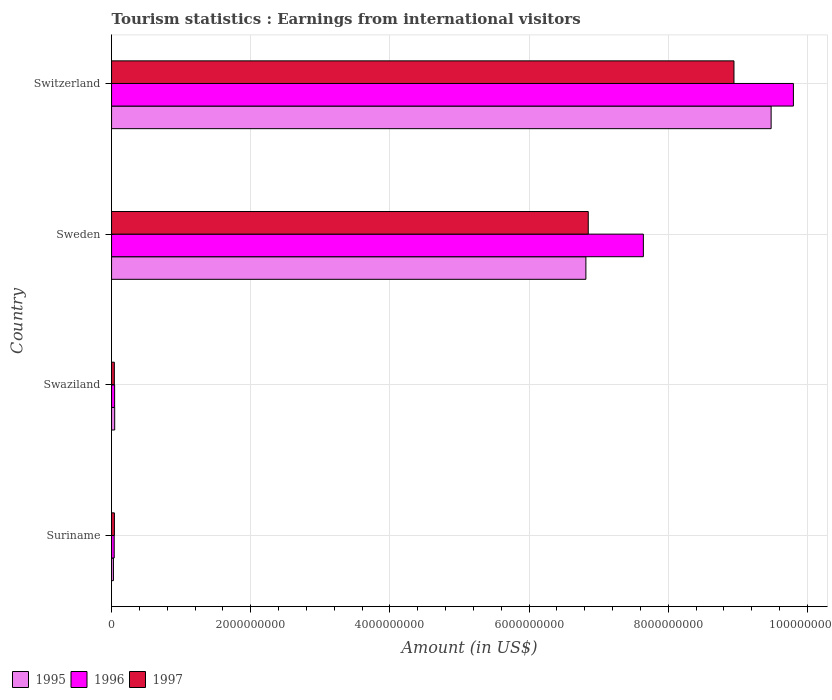How many bars are there on the 4th tick from the top?
Offer a terse response. 3. How many bars are there on the 3rd tick from the bottom?
Ensure brevity in your answer.  3. What is the label of the 2nd group of bars from the top?
Keep it short and to the point. Sweden. What is the earnings from international visitors in 1996 in Swaziland?
Your answer should be compact. 4.40e+07. Across all countries, what is the maximum earnings from international visitors in 1995?
Your answer should be very brief. 9.48e+09. Across all countries, what is the minimum earnings from international visitors in 1996?
Your answer should be compact. 3.80e+07. In which country was the earnings from international visitors in 1996 maximum?
Your answer should be very brief. Switzerland. In which country was the earnings from international visitors in 1996 minimum?
Your answer should be compact. Suriname. What is the total earnings from international visitors in 1996 in the graph?
Provide a short and direct response. 1.75e+1. What is the difference between the earnings from international visitors in 1996 in Swaziland and that in Sweden?
Provide a short and direct response. -7.60e+09. What is the difference between the earnings from international visitors in 1997 in Suriname and the earnings from international visitors in 1996 in Swaziland?
Keep it short and to the point. -3.00e+06. What is the average earnings from international visitors in 1997 per country?
Provide a succinct answer. 3.97e+09. What is the difference between the earnings from international visitors in 1996 and earnings from international visitors in 1995 in Sweden?
Offer a terse response. 8.26e+08. What is the ratio of the earnings from international visitors in 1995 in Suriname to that in Switzerland?
Ensure brevity in your answer.  0. Is the earnings from international visitors in 1996 in Sweden less than that in Switzerland?
Your response must be concise. Yes. Is the difference between the earnings from international visitors in 1996 in Swaziland and Sweden greater than the difference between the earnings from international visitors in 1995 in Swaziland and Sweden?
Keep it short and to the point. No. What is the difference between the highest and the second highest earnings from international visitors in 1997?
Give a very brief answer. 2.09e+09. What is the difference between the highest and the lowest earnings from international visitors in 1996?
Make the answer very short. 9.76e+09. What does the 2nd bar from the top in Swaziland represents?
Offer a very short reply. 1996. Are all the bars in the graph horizontal?
Your answer should be very brief. Yes. What is the difference between two consecutive major ticks on the X-axis?
Provide a short and direct response. 2.00e+09. Are the values on the major ticks of X-axis written in scientific E-notation?
Ensure brevity in your answer.  No. What is the title of the graph?
Give a very brief answer. Tourism statistics : Earnings from international visitors. What is the label or title of the X-axis?
Provide a succinct answer. Amount (in US$). What is the Amount (in US$) of 1995 in Suriname?
Your answer should be very brief. 2.70e+07. What is the Amount (in US$) in 1996 in Suriname?
Your answer should be compact. 3.80e+07. What is the Amount (in US$) in 1997 in Suriname?
Give a very brief answer. 4.10e+07. What is the Amount (in US$) of 1995 in Swaziland?
Provide a short and direct response. 4.50e+07. What is the Amount (in US$) of 1996 in Swaziland?
Offer a terse response. 4.40e+07. What is the Amount (in US$) in 1997 in Swaziland?
Provide a succinct answer. 4.00e+07. What is the Amount (in US$) of 1995 in Sweden?
Offer a very short reply. 6.82e+09. What is the Amount (in US$) of 1996 in Sweden?
Provide a succinct answer. 7.64e+09. What is the Amount (in US$) of 1997 in Sweden?
Offer a terse response. 6.85e+09. What is the Amount (in US$) in 1995 in Switzerland?
Provide a short and direct response. 9.48e+09. What is the Amount (in US$) of 1996 in Switzerland?
Ensure brevity in your answer.  9.80e+09. What is the Amount (in US$) in 1997 in Switzerland?
Make the answer very short. 8.94e+09. Across all countries, what is the maximum Amount (in US$) of 1995?
Offer a terse response. 9.48e+09. Across all countries, what is the maximum Amount (in US$) of 1996?
Offer a terse response. 9.80e+09. Across all countries, what is the maximum Amount (in US$) of 1997?
Provide a short and direct response. 8.94e+09. Across all countries, what is the minimum Amount (in US$) in 1995?
Provide a short and direct response. 2.70e+07. Across all countries, what is the minimum Amount (in US$) in 1996?
Provide a short and direct response. 3.80e+07. Across all countries, what is the minimum Amount (in US$) of 1997?
Keep it short and to the point. 4.00e+07. What is the total Amount (in US$) of 1995 in the graph?
Your response must be concise. 1.64e+1. What is the total Amount (in US$) in 1996 in the graph?
Provide a short and direct response. 1.75e+1. What is the total Amount (in US$) of 1997 in the graph?
Offer a very short reply. 1.59e+1. What is the difference between the Amount (in US$) in 1995 in Suriname and that in Swaziland?
Give a very brief answer. -1.80e+07. What is the difference between the Amount (in US$) in 1996 in Suriname and that in Swaziland?
Provide a succinct answer. -6.00e+06. What is the difference between the Amount (in US$) in 1997 in Suriname and that in Swaziland?
Offer a very short reply. 1.00e+06. What is the difference between the Amount (in US$) in 1995 in Suriname and that in Sweden?
Provide a short and direct response. -6.79e+09. What is the difference between the Amount (in US$) of 1996 in Suriname and that in Sweden?
Your response must be concise. -7.60e+09. What is the difference between the Amount (in US$) of 1997 in Suriname and that in Sweden?
Your answer should be compact. -6.81e+09. What is the difference between the Amount (in US$) in 1995 in Suriname and that in Switzerland?
Ensure brevity in your answer.  -9.45e+09. What is the difference between the Amount (in US$) of 1996 in Suriname and that in Switzerland?
Give a very brief answer. -9.76e+09. What is the difference between the Amount (in US$) of 1997 in Suriname and that in Switzerland?
Your answer should be compact. -8.90e+09. What is the difference between the Amount (in US$) of 1995 in Swaziland and that in Sweden?
Give a very brief answer. -6.77e+09. What is the difference between the Amount (in US$) of 1996 in Swaziland and that in Sweden?
Your answer should be compact. -7.60e+09. What is the difference between the Amount (in US$) of 1997 in Swaziland and that in Sweden?
Keep it short and to the point. -6.81e+09. What is the difference between the Amount (in US$) of 1995 in Swaziland and that in Switzerland?
Provide a succinct answer. -9.43e+09. What is the difference between the Amount (in US$) in 1996 in Swaziland and that in Switzerland?
Provide a succinct answer. -9.75e+09. What is the difference between the Amount (in US$) in 1997 in Swaziland and that in Switzerland?
Keep it short and to the point. -8.90e+09. What is the difference between the Amount (in US$) in 1995 in Sweden and that in Switzerland?
Your response must be concise. -2.66e+09. What is the difference between the Amount (in US$) of 1996 in Sweden and that in Switzerland?
Your response must be concise. -2.16e+09. What is the difference between the Amount (in US$) of 1997 in Sweden and that in Switzerland?
Your answer should be compact. -2.09e+09. What is the difference between the Amount (in US$) of 1995 in Suriname and the Amount (in US$) of 1996 in Swaziland?
Make the answer very short. -1.70e+07. What is the difference between the Amount (in US$) of 1995 in Suriname and the Amount (in US$) of 1997 in Swaziland?
Your answer should be compact. -1.30e+07. What is the difference between the Amount (in US$) of 1996 in Suriname and the Amount (in US$) of 1997 in Swaziland?
Your answer should be compact. -2.00e+06. What is the difference between the Amount (in US$) in 1995 in Suriname and the Amount (in US$) in 1996 in Sweden?
Provide a succinct answer. -7.62e+09. What is the difference between the Amount (in US$) of 1995 in Suriname and the Amount (in US$) of 1997 in Sweden?
Provide a short and direct response. -6.82e+09. What is the difference between the Amount (in US$) in 1996 in Suriname and the Amount (in US$) in 1997 in Sweden?
Make the answer very short. -6.81e+09. What is the difference between the Amount (in US$) in 1995 in Suriname and the Amount (in US$) in 1996 in Switzerland?
Provide a short and direct response. -9.77e+09. What is the difference between the Amount (in US$) in 1995 in Suriname and the Amount (in US$) in 1997 in Switzerland?
Your response must be concise. -8.92e+09. What is the difference between the Amount (in US$) in 1996 in Suriname and the Amount (in US$) in 1997 in Switzerland?
Ensure brevity in your answer.  -8.91e+09. What is the difference between the Amount (in US$) in 1995 in Swaziland and the Amount (in US$) in 1996 in Sweden?
Your answer should be very brief. -7.60e+09. What is the difference between the Amount (in US$) in 1995 in Swaziland and the Amount (in US$) in 1997 in Sweden?
Offer a terse response. -6.80e+09. What is the difference between the Amount (in US$) of 1996 in Swaziland and the Amount (in US$) of 1997 in Sweden?
Keep it short and to the point. -6.81e+09. What is the difference between the Amount (in US$) in 1995 in Swaziland and the Amount (in US$) in 1996 in Switzerland?
Provide a short and direct response. -9.75e+09. What is the difference between the Amount (in US$) in 1995 in Swaziland and the Amount (in US$) in 1997 in Switzerland?
Offer a very short reply. -8.90e+09. What is the difference between the Amount (in US$) in 1996 in Swaziland and the Amount (in US$) in 1997 in Switzerland?
Your answer should be very brief. -8.90e+09. What is the difference between the Amount (in US$) in 1995 in Sweden and the Amount (in US$) in 1996 in Switzerland?
Provide a short and direct response. -2.98e+09. What is the difference between the Amount (in US$) in 1995 in Sweden and the Amount (in US$) in 1997 in Switzerland?
Offer a very short reply. -2.13e+09. What is the difference between the Amount (in US$) in 1996 in Sweden and the Amount (in US$) in 1997 in Switzerland?
Your response must be concise. -1.30e+09. What is the average Amount (in US$) of 1995 per country?
Give a very brief answer. 4.09e+09. What is the average Amount (in US$) in 1996 per country?
Offer a terse response. 4.38e+09. What is the average Amount (in US$) in 1997 per country?
Provide a short and direct response. 3.97e+09. What is the difference between the Amount (in US$) in 1995 and Amount (in US$) in 1996 in Suriname?
Keep it short and to the point. -1.10e+07. What is the difference between the Amount (in US$) of 1995 and Amount (in US$) of 1997 in Suriname?
Give a very brief answer. -1.40e+07. What is the difference between the Amount (in US$) of 1995 and Amount (in US$) of 1996 in Swaziland?
Provide a succinct answer. 1.00e+06. What is the difference between the Amount (in US$) in 1996 and Amount (in US$) in 1997 in Swaziland?
Ensure brevity in your answer.  4.00e+06. What is the difference between the Amount (in US$) in 1995 and Amount (in US$) in 1996 in Sweden?
Your answer should be compact. -8.26e+08. What is the difference between the Amount (in US$) of 1995 and Amount (in US$) of 1997 in Sweden?
Provide a short and direct response. -3.40e+07. What is the difference between the Amount (in US$) in 1996 and Amount (in US$) in 1997 in Sweden?
Offer a terse response. 7.92e+08. What is the difference between the Amount (in US$) of 1995 and Amount (in US$) of 1996 in Switzerland?
Offer a very short reply. -3.20e+08. What is the difference between the Amount (in US$) in 1995 and Amount (in US$) in 1997 in Switzerland?
Offer a terse response. 5.34e+08. What is the difference between the Amount (in US$) in 1996 and Amount (in US$) in 1997 in Switzerland?
Keep it short and to the point. 8.54e+08. What is the ratio of the Amount (in US$) of 1995 in Suriname to that in Swaziland?
Your answer should be very brief. 0.6. What is the ratio of the Amount (in US$) in 1996 in Suriname to that in Swaziland?
Offer a very short reply. 0.86. What is the ratio of the Amount (in US$) in 1995 in Suriname to that in Sweden?
Provide a succinct answer. 0. What is the ratio of the Amount (in US$) in 1996 in Suriname to that in Sweden?
Your response must be concise. 0.01. What is the ratio of the Amount (in US$) of 1997 in Suriname to that in Sweden?
Your response must be concise. 0.01. What is the ratio of the Amount (in US$) of 1995 in Suriname to that in Switzerland?
Your response must be concise. 0. What is the ratio of the Amount (in US$) of 1996 in Suriname to that in Switzerland?
Provide a succinct answer. 0. What is the ratio of the Amount (in US$) in 1997 in Suriname to that in Switzerland?
Offer a very short reply. 0. What is the ratio of the Amount (in US$) in 1995 in Swaziland to that in Sweden?
Your answer should be very brief. 0.01. What is the ratio of the Amount (in US$) of 1996 in Swaziland to that in Sweden?
Your answer should be compact. 0.01. What is the ratio of the Amount (in US$) in 1997 in Swaziland to that in Sweden?
Provide a short and direct response. 0.01. What is the ratio of the Amount (in US$) in 1995 in Swaziland to that in Switzerland?
Your response must be concise. 0. What is the ratio of the Amount (in US$) in 1996 in Swaziland to that in Switzerland?
Provide a succinct answer. 0. What is the ratio of the Amount (in US$) in 1997 in Swaziland to that in Switzerland?
Keep it short and to the point. 0. What is the ratio of the Amount (in US$) in 1995 in Sweden to that in Switzerland?
Keep it short and to the point. 0.72. What is the ratio of the Amount (in US$) in 1996 in Sweden to that in Switzerland?
Keep it short and to the point. 0.78. What is the ratio of the Amount (in US$) in 1997 in Sweden to that in Switzerland?
Keep it short and to the point. 0.77. What is the difference between the highest and the second highest Amount (in US$) of 1995?
Provide a succinct answer. 2.66e+09. What is the difference between the highest and the second highest Amount (in US$) in 1996?
Ensure brevity in your answer.  2.16e+09. What is the difference between the highest and the second highest Amount (in US$) of 1997?
Offer a terse response. 2.09e+09. What is the difference between the highest and the lowest Amount (in US$) in 1995?
Offer a very short reply. 9.45e+09. What is the difference between the highest and the lowest Amount (in US$) in 1996?
Make the answer very short. 9.76e+09. What is the difference between the highest and the lowest Amount (in US$) in 1997?
Your response must be concise. 8.90e+09. 